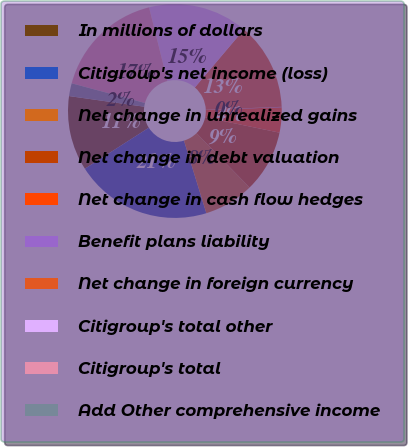Convert chart to OTSL. <chart><loc_0><loc_0><loc_500><loc_500><pie_chart><fcel>In millions of dollars<fcel>Citigroup's net income (loss)<fcel>Net change in unrealized gains<fcel>Net change in debt valuation<fcel>Net change in cash flow hedges<fcel>Benefit plans liability<fcel>Net change in foreign currency<fcel>Citigroup's total other<fcel>Citigroup's total<fcel>Add Other comprehensive income<nl><fcel>11.31%<fcel>20.69%<fcel>7.56%<fcel>9.44%<fcel>3.81%<fcel>0.06%<fcel>13.19%<fcel>15.06%<fcel>16.94%<fcel>1.94%<nl></chart> 